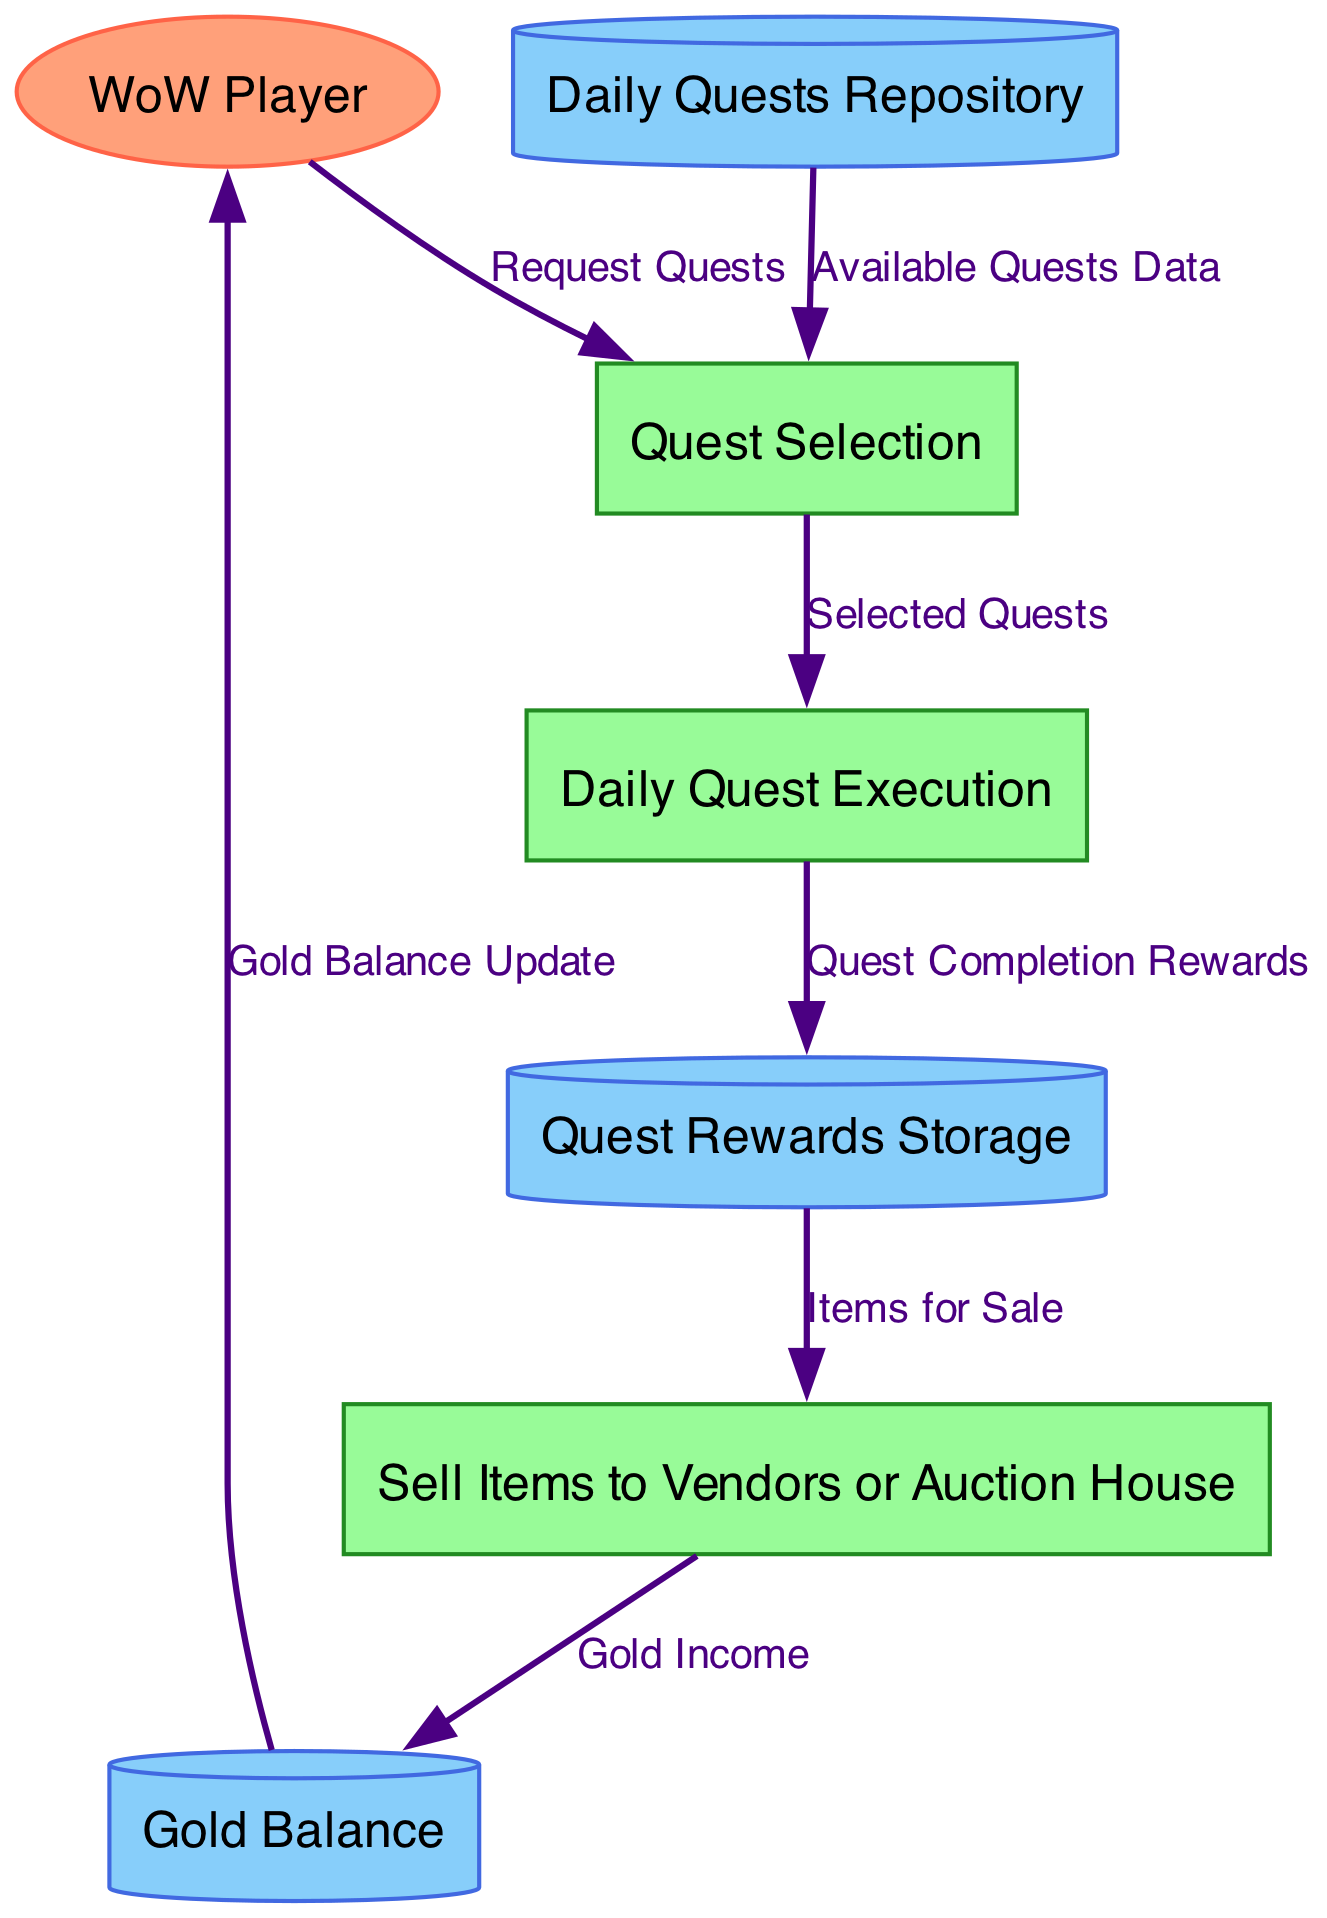What is the first step in the quest completion cycle? The first step is "Quest Selection," where the player requests quests.
Answer: Quest Selection How many external entities are present in the diagram? There is one external entity, which is the "WoW Player."
Answer: one What type of process occurs after the "Quest Selection" process? The process that occurs after "Quest Selection" is "Daily Quest Execution."
Answer: Daily Quest Execution What are the items that come after the completion of a quest? The items are labeled as "Quest Completion Rewards," which flow into the "Quest Rewards Storage."
Answer: Quest Completion Rewards Which data store holds the player's current gold? The data store that holds the player's current gold is called "Gold Balance."
Answer: Gold Balance What is the final action involving completed quests? The final action is to "Sell Items to Vendors or Auction House." This is where items generated from quests are sold.
Answer: Sell Items to Vendors or Auction House What flow comes from "Sell Items to Vendors or Auction House" to "Gold Balance"? The flow is labeled "Gold Income," which represents the gold received from selling items.
Answer: Gold Income How does the player receive updates on their gold balance? The update occurs through a flow labeled "Gold Balance Update," which goes from "Gold Balance" back to the "WoW Player."
Answer: Gold Balance Update What is the total number of processes in this diagram? There are three processes in total: "Quest Selection," "Daily Quest Execution," and "Sell Items to Vendors or Auction House."
Answer: three 